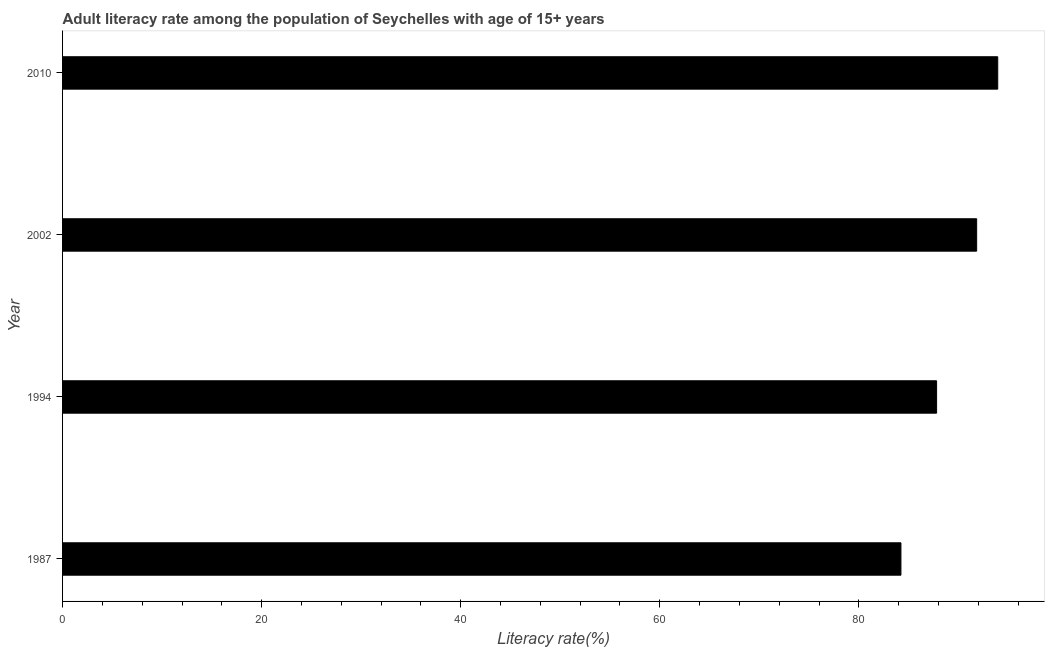Does the graph contain any zero values?
Give a very brief answer. No. What is the title of the graph?
Offer a terse response. Adult literacy rate among the population of Seychelles with age of 15+ years. What is the label or title of the X-axis?
Your answer should be very brief. Literacy rate(%). What is the adult literacy rate in 2002?
Give a very brief answer. 91.84. Across all years, what is the maximum adult literacy rate?
Offer a terse response. 93.95. Across all years, what is the minimum adult literacy rate?
Offer a terse response. 84.23. What is the sum of the adult literacy rate?
Make the answer very short. 357.83. What is the difference between the adult literacy rate in 1994 and 2010?
Your answer should be very brief. -6.14. What is the average adult literacy rate per year?
Your response must be concise. 89.46. What is the median adult literacy rate?
Offer a terse response. 89.82. Is the difference between the adult literacy rate in 1987 and 2002 greater than the difference between any two years?
Offer a very short reply. No. What is the difference between the highest and the second highest adult literacy rate?
Keep it short and to the point. 2.12. Is the sum of the adult literacy rate in 1987 and 2010 greater than the maximum adult literacy rate across all years?
Offer a terse response. Yes. What is the difference between the highest and the lowest adult literacy rate?
Your answer should be compact. 9.73. In how many years, is the adult literacy rate greater than the average adult literacy rate taken over all years?
Your response must be concise. 2. How many years are there in the graph?
Your answer should be compact. 4. What is the difference between two consecutive major ticks on the X-axis?
Ensure brevity in your answer.  20. Are the values on the major ticks of X-axis written in scientific E-notation?
Offer a terse response. No. What is the Literacy rate(%) in 1987?
Your answer should be compact. 84.23. What is the Literacy rate(%) of 1994?
Offer a very short reply. 87.81. What is the Literacy rate(%) in 2002?
Provide a short and direct response. 91.84. What is the Literacy rate(%) of 2010?
Provide a succinct answer. 93.95. What is the difference between the Literacy rate(%) in 1987 and 1994?
Give a very brief answer. -3.58. What is the difference between the Literacy rate(%) in 1987 and 2002?
Your response must be concise. -7.61. What is the difference between the Literacy rate(%) in 1987 and 2010?
Offer a terse response. -9.73. What is the difference between the Literacy rate(%) in 1994 and 2002?
Give a very brief answer. -4.03. What is the difference between the Literacy rate(%) in 1994 and 2010?
Ensure brevity in your answer.  -6.14. What is the difference between the Literacy rate(%) in 2002 and 2010?
Ensure brevity in your answer.  -2.12. What is the ratio of the Literacy rate(%) in 1987 to that in 1994?
Your answer should be very brief. 0.96. What is the ratio of the Literacy rate(%) in 1987 to that in 2002?
Offer a terse response. 0.92. What is the ratio of the Literacy rate(%) in 1987 to that in 2010?
Your answer should be compact. 0.9. What is the ratio of the Literacy rate(%) in 1994 to that in 2002?
Your answer should be very brief. 0.96. What is the ratio of the Literacy rate(%) in 1994 to that in 2010?
Your answer should be very brief. 0.94. 